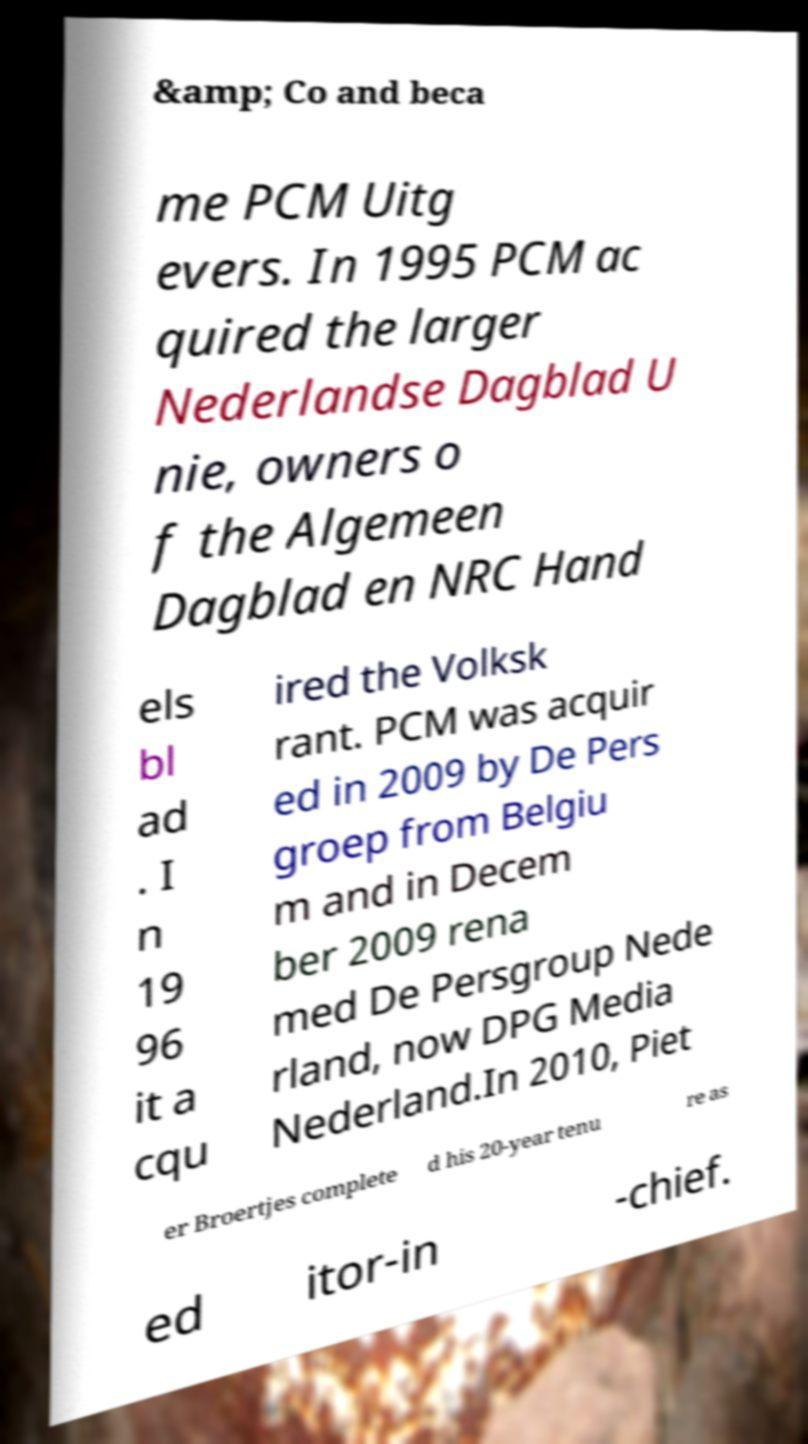There's text embedded in this image that I need extracted. Can you transcribe it verbatim? &amp; Co and beca me PCM Uitg evers. In 1995 PCM ac quired the larger Nederlandse Dagblad U nie, owners o f the Algemeen Dagblad en NRC Hand els bl ad . I n 19 96 it a cqu ired the Volksk rant. PCM was acquir ed in 2009 by De Pers groep from Belgiu m and in Decem ber 2009 rena med De Persgroup Nede rland, now DPG Media Nederland.In 2010, Piet er Broertjes complete d his 20-year tenu re as ed itor-in -chief. 